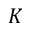<formula> <loc_0><loc_0><loc_500><loc_500>K</formula> 